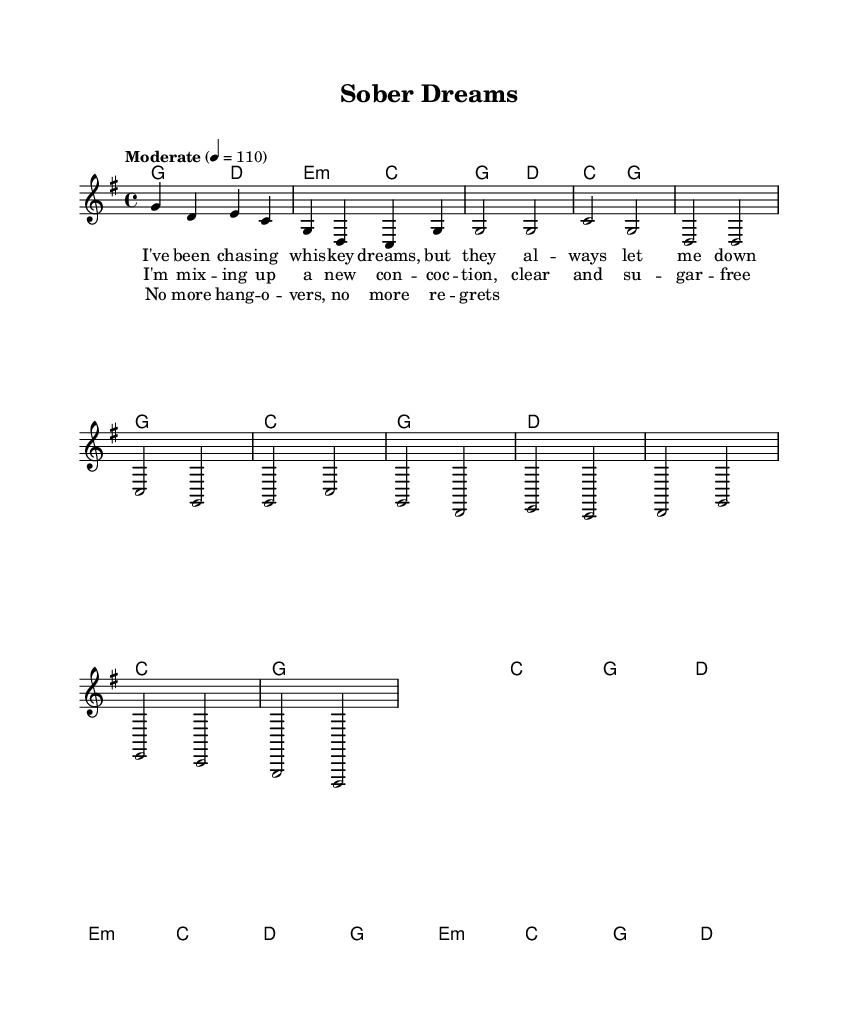What is the key signature of this music? The key signature is G major, which has one sharp (F#). This can be identified in the initial section of the music, where the notes are laid out with the sharp indicated at the beginning.
Answer: G major What is the time signature of this music? The time signature is 4/4, which means there are four beats in a measure and the quarter note gets one beat. This is shown at the beginning of the piece where the time signature is explicitly notated.
Answer: 4/4 What is the tempo marking for this music? The tempo marking is "Moderate" at 110 beats per minute. This indicates the speed at which the music should be played, and is specified in the initial section of the score.
Answer: Moderate 110 How many measures are in the verse section? The verse section consists of 8 measures. By counting the measures indicated in the score under the verse section, you can determine the total.
Answer: 8 measures Which chord is used in the chorus? The chord used in the chorus is C major. This can be determined by looking at the chord symbols directly above the melody in the chorus section of the sheet music.
Answer: C major What theme does this music convey in lyrics? The lyrics convey a theme of overcoming challenges and pursuing dreams, as suggested by lines such as “chasing whiskey dreams” and “no more hangovers.” This theme is evident in the content of the lyrics presented with the score.
Answer: Overcoming challenges and pursuing dreams 